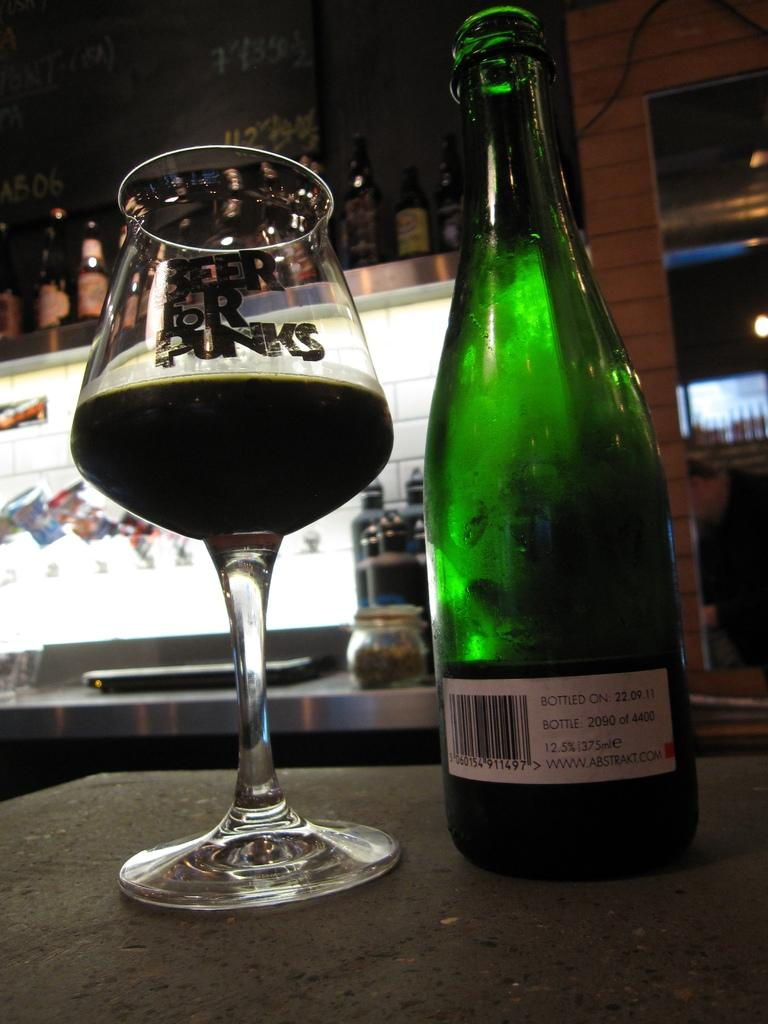What is in the glass that is visible in the image? There is a drink in the glass that is visible in the image. What other beverage container can be seen in the image? There is a bottle in the image. Where are the glass and the bottle located in the image? Both the glass and the bottle are placed on a table. What can be seen in the background of the image? In the background of the image, there are bottles in a rack, a wall, glasses, and a jar. What type of harmony is being played by the father in the image? There is no father or any indication of music or harmony in the image. 